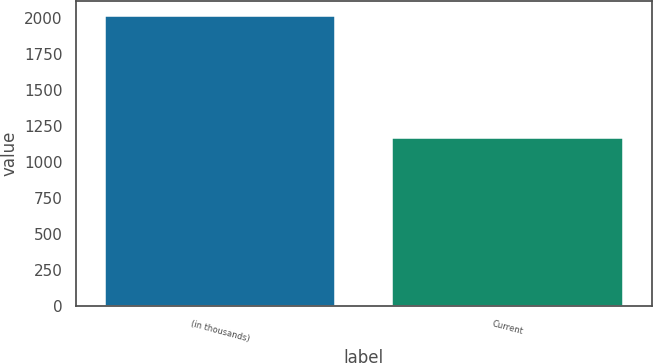Convert chart to OTSL. <chart><loc_0><loc_0><loc_500><loc_500><bar_chart><fcel>(in thousands)<fcel>Current<nl><fcel>2017<fcel>1168<nl></chart> 